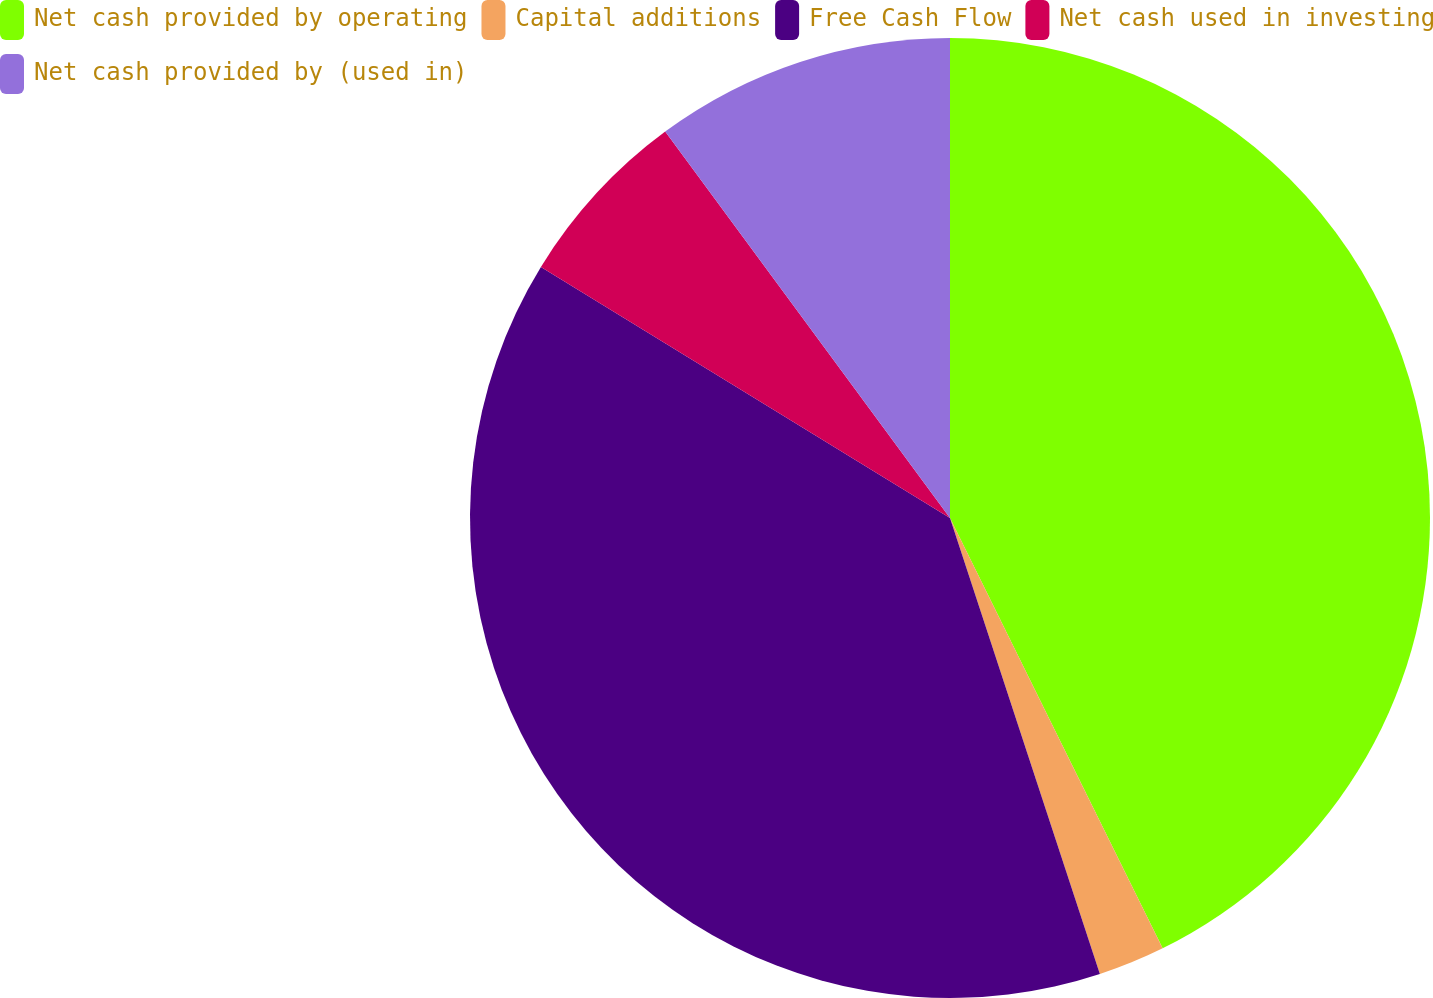<chart> <loc_0><loc_0><loc_500><loc_500><pie_chart><fcel>Net cash provided by operating<fcel>Capital additions<fcel>Free Cash Flow<fcel>Net cash used in investing<fcel>Net cash provided by (used in)<nl><fcel>42.7%<fcel>2.25%<fcel>38.82%<fcel>6.13%<fcel>10.11%<nl></chart> 